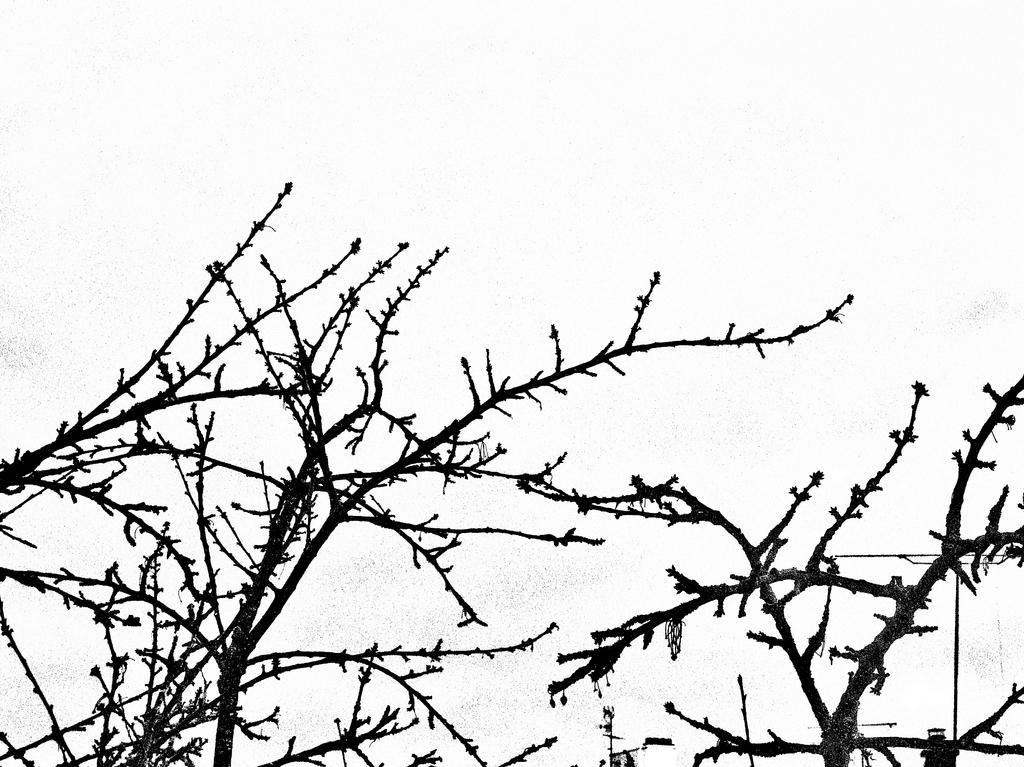What type of tree is in the image? There is a dry tree in the image. What can be seen in the background of the image? There is a sky visible in the background of the image. What memory does the tree have in the image? Trees do not have memories, so this question cannot be answered definitively from the image. 